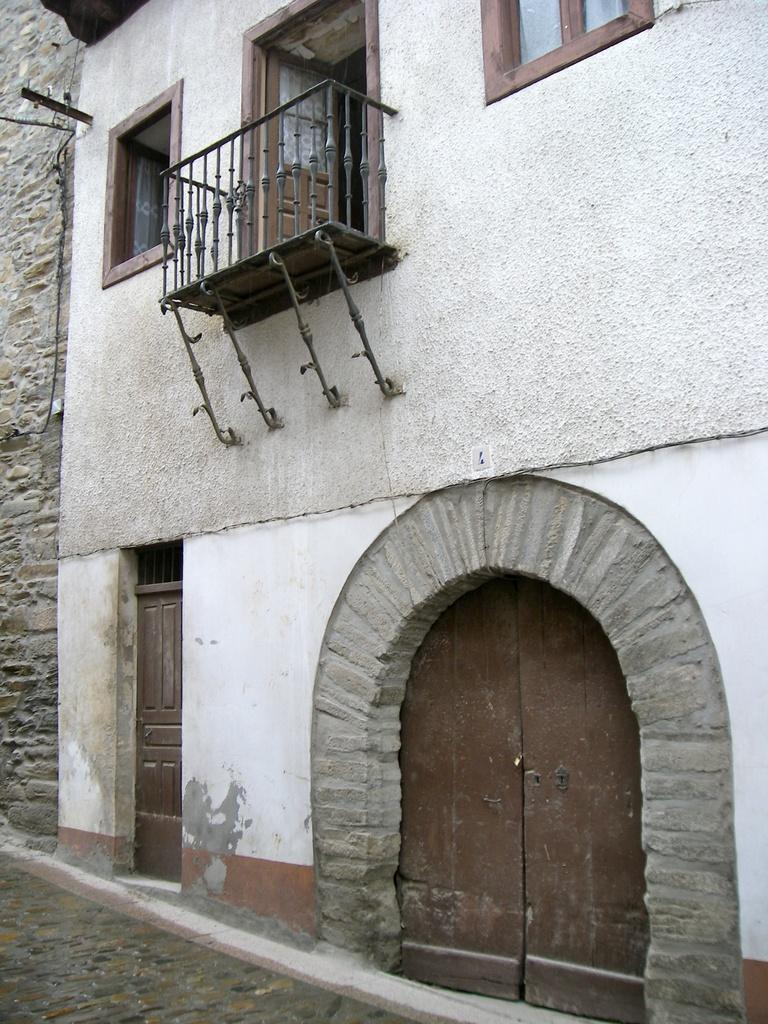What type of structure is visible in the image? There is a building in the image. What features can be seen on the building? The building has windows and doors. Can you describe any other elements in the image? There is a grille in the image. What is the texture of the partner's hand in the image? There is no partner or hand present in the image; it only features a building with windows, doors, and a grille. 